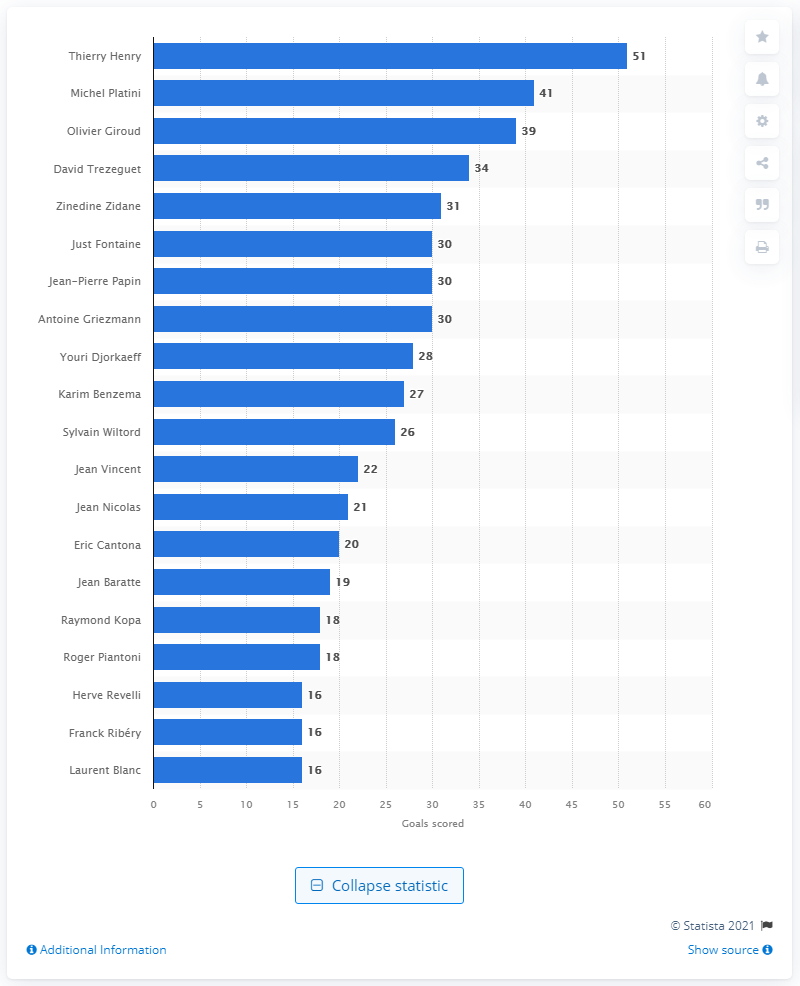Point out several critical features in this image. In December 2019, Thierry Henry was the top goal scorer for the French national football team. Thierry Henry scored 51 goals with the French football team. 